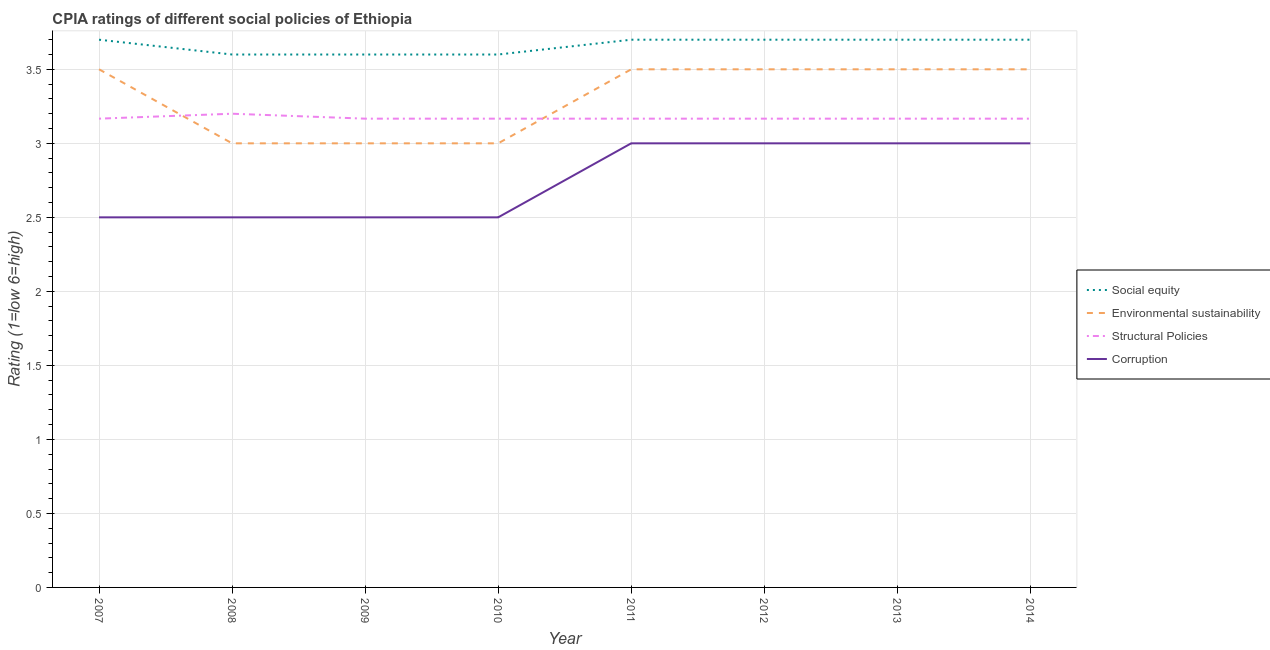How many different coloured lines are there?
Provide a succinct answer. 4. Is the number of lines equal to the number of legend labels?
Offer a terse response. Yes. Across all years, what is the maximum cpia rating of environmental sustainability?
Your answer should be compact. 3.5. What is the total cpia rating of social equity in the graph?
Keep it short and to the point. 29.3. What is the difference between the cpia rating of corruption in 2013 and that in 2014?
Keep it short and to the point. 0. What is the difference between the cpia rating of environmental sustainability in 2009 and the cpia rating of structural policies in 2010?
Provide a short and direct response. -0.17. What is the average cpia rating of structural policies per year?
Offer a terse response. 3.17. In the year 2013, what is the difference between the cpia rating of social equity and cpia rating of structural policies?
Provide a succinct answer. 0.53. In how many years, is the cpia rating of structural policies greater than 3?
Keep it short and to the point. 8. What is the ratio of the cpia rating of structural policies in 2009 to that in 2014?
Keep it short and to the point. 1. What is the difference between the highest and the second highest cpia rating of corruption?
Provide a succinct answer. 0. Is it the case that in every year, the sum of the cpia rating of social equity and cpia rating of environmental sustainability is greater than the cpia rating of structural policies?
Keep it short and to the point. Yes. How many years are there in the graph?
Ensure brevity in your answer.  8. Are the values on the major ticks of Y-axis written in scientific E-notation?
Your response must be concise. No. Does the graph contain any zero values?
Offer a very short reply. No. How many legend labels are there?
Provide a succinct answer. 4. What is the title of the graph?
Provide a short and direct response. CPIA ratings of different social policies of Ethiopia. Does "Social Awareness" appear as one of the legend labels in the graph?
Give a very brief answer. No. What is the label or title of the X-axis?
Provide a short and direct response. Year. What is the label or title of the Y-axis?
Your answer should be compact. Rating (1=low 6=high). What is the Rating (1=low 6=high) of Environmental sustainability in 2007?
Ensure brevity in your answer.  3.5. What is the Rating (1=low 6=high) of Structural Policies in 2007?
Offer a very short reply. 3.17. What is the Rating (1=low 6=high) of Corruption in 2007?
Provide a succinct answer. 2.5. What is the Rating (1=low 6=high) of Corruption in 2008?
Your answer should be very brief. 2.5. What is the Rating (1=low 6=high) in Structural Policies in 2009?
Keep it short and to the point. 3.17. What is the Rating (1=low 6=high) of Social equity in 2010?
Keep it short and to the point. 3.6. What is the Rating (1=low 6=high) of Environmental sustainability in 2010?
Make the answer very short. 3. What is the Rating (1=low 6=high) in Structural Policies in 2010?
Your answer should be compact. 3.17. What is the Rating (1=low 6=high) of Corruption in 2010?
Your response must be concise. 2.5. What is the Rating (1=low 6=high) in Environmental sustainability in 2011?
Provide a succinct answer. 3.5. What is the Rating (1=low 6=high) in Structural Policies in 2011?
Offer a very short reply. 3.17. What is the Rating (1=low 6=high) in Structural Policies in 2012?
Your answer should be very brief. 3.17. What is the Rating (1=low 6=high) of Corruption in 2012?
Offer a very short reply. 3. What is the Rating (1=low 6=high) of Structural Policies in 2013?
Your response must be concise. 3.17. What is the Rating (1=low 6=high) of Corruption in 2013?
Your response must be concise. 3. What is the Rating (1=low 6=high) in Social equity in 2014?
Provide a succinct answer. 3.7. What is the Rating (1=low 6=high) in Structural Policies in 2014?
Your response must be concise. 3.17. Across all years, what is the maximum Rating (1=low 6=high) in Social equity?
Provide a succinct answer. 3.7. Across all years, what is the maximum Rating (1=low 6=high) in Structural Policies?
Offer a very short reply. 3.2. Across all years, what is the minimum Rating (1=low 6=high) of Social equity?
Keep it short and to the point. 3.6. Across all years, what is the minimum Rating (1=low 6=high) in Structural Policies?
Ensure brevity in your answer.  3.17. What is the total Rating (1=low 6=high) of Social equity in the graph?
Your answer should be very brief. 29.3. What is the total Rating (1=low 6=high) in Structural Policies in the graph?
Ensure brevity in your answer.  25.37. What is the total Rating (1=low 6=high) of Corruption in the graph?
Your answer should be very brief. 22. What is the difference between the Rating (1=low 6=high) in Social equity in 2007 and that in 2008?
Keep it short and to the point. 0.1. What is the difference between the Rating (1=low 6=high) in Structural Policies in 2007 and that in 2008?
Provide a short and direct response. -0.03. What is the difference between the Rating (1=low 6=high) in Structural Policies in 2007 and that in 2009?
Your answer should be very brief. 0. What is the difference between the Rating (1=low 6=high) in Corruption in 2007 and that in 2010?
Your answer should be very brief. 0. What is the difference between the Rating (1=low 6=high) in Social equity in 2007 and that in 2011?
Your response must be concise. 0. What is the difference between the Rating (1=low 6=high) in Environmental sustainability in 2007 and that in 2011?
Offer a very short reply. 0. What is the difference between the Rating (1=low 6=high) in Structural Policies in 2007 and that in 2011?
Keep it short and to the point. 0. What is the difference between the Rating (1=low 6=high) of Corruption in 2007 and that in 2011?
Make the answer very short. -0.5. What is the difference between the Rating (1=low 6=high) in Social equity in 2007 and that in 2012?
Offer a terse response. 0. What is the difference between the Rating (1=low 6=high) of Environmental sustainability in 2007 and that in 2012?
Provide a succinct answer. 0. What is the difference between the Rating (1=low 6=high) in Corruption in 2007 and that in 2012?
Make the answer very short. -0.5. What is the difference between the Rating (1=low 6=high) of Environmental sustainability in 2007 and that in 2013?
Your answer should be compact. 0. What is the difference between the Rating (1=low 6=high) in Structural Policies in 2007 and that in 2013?
Your answer should be very brief. 0. What is the difference between the Rating (1=low 6=high) in Social equity in 2007 and that in 2014?
Provide a succinct answer. 0. What is the difference between the Rating (1=low 6=high) of Environmental sustainability in 2007 and that in 2014?
Offer a very short reply. 0. What is the difference between the Rating (1=low 6=high) of Corruption in 2007 and that in 2014?
Offer a very short reply. -0.5. What is the difference between the Rating (1=low 6=high) of Social equity in 2008 and that in 2009?
Provide a short and direct response. 0. What is the difference between the Rating (1=low 6=high) in Corruption in 2008 and that in 2009?
Offer a very short reply. 0. What is the difference between the Rating (1=low 6=high) of Social equity in 2008 and that in 2010?
Provide a succinct answer. 0. What is the difference between the Rating (1=low 6=high) of Structural Policies in 2008 and that in 2010?
Provide a short and direct response. 0.03. What is the difference between the Rating (1=low 6=high) of Environmental sustainability in 2008 and that in 2011?
Keep it short and to the point. -0.5. What is the difference between the Rating (1=low 6=high) in Corruption in 2008 and that in 2011?
Make the answer very short. -0.5. What is the difference between the Rating (1=low 6=high) in Structural Policies in 2008 and that in 2012?
Provide a short and direct response. 0.03. What is the difference between the Rating (1=low 6=high) in Social equity in 2008 and that in 2013?
Give a very brief answer. -0.1. What is the difference between the Rating (1=low 6=high) of Environmental sustainability in 2008 and that in 2013?
Offer a very short reply. -0.5. What is the difference between the Rating (1=low 6=high) of Environmental sustainability in 2008 and that in 2014?
Ensure brevity in your answer.  -0.5. What is the difference between the Rating (1=low 6=high) of Structural Policies in 2008 and that in 2014?
Provide a succinct answer. 0.03. What is the difference between the Rating (1=low 6=high) in Social equity in 2009 and that in 2010?
Give a very brief answer. 0. What is the difference between the Rating (1=low 6=high) in Environmental sustainability in 2009 and that in 2010?
Your response must be concise. 0. What is the difference between the Rating (1=low 6=high) in Structural Policies in 2009 and that in 2010?
Offer a very short reply. 0. What is the difference between the Rating (1=low 6=high) in Corruption in 2009 and that in 2010?
Provide a short and direct response. 0. What is the difference between the Rating (1=low 6=high) in Social equity in 2009 and that in 2011?
Ensure brevity in your answer.  -0.1. What is the difference between the Rating (1=low 6=high) of Environmental sustainability in 2009 and that in 2011?
Provide a succinct answer. -0.5. What is the difference between the Rating (1=low 6=high) in Corruption in 2009 and that in 2011?
Ensure brevity in your answer.  -0.5. What is the difference between the Rating (1=low 6=high) in Social equity in 2009 and that in 2012?
Your answer should be very brief. -0.1. What is the difference between the Rating (1=low 6=high) in Environmental sustainability in 2009 and that in 2012?
Keep it short and to the point. -0.5. What is the difference between the Rating (1=low 6=high) in Structural Policies in 2009 and that in 2012?
Your answer should be very brief. 0. What is the difference between the Rating (1=low 6=high) of Social equity in 2009 and that in 2013?
Provide a succinct answer. -0.1. What is the difference between the Rating (1=low 6=high) in Environmental sustainability in 2009 and that in 2013?
Offer a terse response. -0.5. What is the difference between the Rating (1=low 6=high) of Structural Policies in 2009 and that in 2013?
Give a very brief answer. 0. What is the difference between the Rating (1=low 6=high) of Social equity in 2009 and that in 2014?
Your answer should be very brief. -0.1. What is the difference between the Rating (1=low 6=high) in Structural Policies in 2009 and that in 2014?
Your answer should be compact. 0. What is the difference between the Rating (1=low 6=high) in Social equity in 2010 and that in 2011?
Your answer should be compact. -0.1. What is the difference between the Rating (1=low 6=high) in Structural Policies in 2010 and that in 2011?
Give a very brief answer. 0. What is the difference between the Rating (1=low 6=high) of Environmental sustainability in 2010 and that in 2012?
Make the answer very short. -0.5. What is the difference between the Rating (1=low 6=high) in Corruption in 2010 and that in 2012?
Make the answer very short. -0.5. What is the difference between the Rating (1=low 6=high) in Social equity in 2010 and that in 2013?
Ensure brevity in your answer.  -0.1. What is the difference between the Rating (1=low 6=high) of Environmental sustainability in 2010 and that in 2013?
Ensure brevity in your answer.  -0.5. What is the difference between the Rating (1=low 6=high) of Corruption in 2010 and that in 2013?
Make the answer very short. -0.5. What is the difference between the Rating (1=low 6=high) in Structural Policies in 2010 and that in 2014?
Make the answer very short. 0. What is the difference between the Rating (1=low 6=high) in Environmental sustainability in 2011 and that in 2012?
Offer a very short reply. 0. What is the difference between the Rating (1=low 6=high) in Corruption in 2011 and that in 2012?
Provide a succinct answer. 0. What is the difference between the Rating (1=low 6=high) in Structural Policies in 2011 and that in 2013?
Provide a succinct answer. 0. What is the difference between the Rating (1=low 6=high) in Environmental sustainability in 2011 and that in 2014?
Keep it short and to the point. 0. What is the difference between the Rating (1=low 6=high) of Corruption in 2011 and that in 2014?
Your answer should be compact. 0. What is the difference between the Rating (1=low 6=high) of Social equity in 2012 and that in 2013?
Give a very brief answer. 0. What is the difference between the Rating (1=low 6=high) in Environmental sustainability in 2012 and that in 2013?
Offer a very short reply. 0. What is the difference between the Rating (1=low 6=high) of Corruption in 2012 and that in 2013?
Keep it short and to the point. 0. What is the difference between the Rating (1=low 6=high) in Social equity in 2012 and that in 2014?
Give a very brief answer. 0. What is the difference between the Rating (1=low 6=high) of Environmental sustainability in 2012 and that in 2014?
Your answer should be compact. 0. What is the difference between the Rating (1=low 6=high) of Structural Policies in 2012 and that in 2014?
Your answer should be compact. 0. What is the difference between the Rating (1=low 6=high) in Environmental sustainability in 2013 and that in 2014?
Keep it short and to the point. 0. What is the difference between the Rating (1=low 6=high) in Structural Policies in 2013 and that in 2014?
Your answer should be very brief. 0. What is the difference between the Rating (1=low 6=high) of Social equity in 2007 and the Rating (1=low 6=high) of Structural Policies in 2008?
Offer a terse response. 0.5. What is the difference between the Rating (1=low 6=high) in Social equity in 2007 and the Rating (1=low 6=high) in Corruption in 2008?
Give a very brief answer. 1.2. What is the difference between the Rating (1=low 6=high) in Structural Policies in 2007 and the Rating (1=low 6=high) in Corruption in 2008?
Make the answer very short. 0.67. What is the difference between the Rating (1=low 6=high) in Social equity in 2007 and the Rating (1=low 6=high) in Environmental sustainability in 2009?
Give a very brief answer. 0.7. What is the difference between the Rating (1=low 6=high) of Social equity in 2007 and the Rating (1=low 6=high) of Structural Policies in 2009?
Ensure brevity in your answer.  0.53. What is the difference between the Rating (1=low 6=high) in Social equity in 2007 and the Rating (1=low 6=high) in Corruption in 2009?
Offer a terse response. 1.2. What is the difference between the Rating (1=low 6=high) in Environmental sustainability in 2007 and the Rating (1=low 6=high) in Structural Policies in 2009?
Provide a succinct answer. 0.33. What is the difference between the Rating (1=low 6=high) of Environmental sustainability in 2007 and the Rating (1=low 6=high) of Corruption in 2009?
Ensure brevity in your answer.  1. What is the difference between the Rating (1=low 6=high) in Social equity in 2007 and the Rating (1=low 6=high) in Environmental sustainability in 2010?
Keep it short and to the point. 0.7. What is the difference between the Rating (1=low 6=high) in Social equity in 2007 and the Rating (1=low 6=high) in Structural Policies in 2010?
Your answer should be very brief. 0.53. What is the difference between the Rating (1=low 6=high) in Social equity in 2007 and the Rating (1=low 6=high) in Corruption in 2010?
Keep it short and to the point. 1.2. What is the difference between the Rating (1=low 6=high) of Environmental sustainability in 2007 and the Rating (1=low 6=high) of Corruption in 2010?
Your response must be concise. 1. What is the difference between the Rating (1=low 6=high) of Social equity in 2007 and the Rating (1=low 6=high) of Environmental sustainability in 2011?
Keep it short and to the point. 0.2. What is the difference between the Rating (1=low 6=high) in Social equity in 2007 and the Rating (1=low 6=high) in Structural Policies in 2011?
Your answer should be very brief. 0.53. What is the difference between the Rating (1=low 6=high) of Environmental sustainability in 2007 and the Rating (1=low 6=high) of Structural Policies in 2011?
Provide a short and direct response. 0.33. What is the difference between the Rating (1=low 6=high) in Social equity in 2007 and the Rating (1=low 6=high) in Structural Policies in 2012?
Make the answer very short. 0.53. What is the difference between the Rating (1=low 6=high) in Environmental sustainability in 2007 and the Rating (1=low 6=high) in Structural Policies in 2012?
Give a very brief answer. 0.33. What is the difference between the Rating (1=low 6=high) of Social equity in 2007 and the Rating (1=low 6=high) of Structural Policies in 2013?
Your response must be concise. 0.53. What is the difference between the Rating (1=low 6=high) of Environmental sustainability in 2007 and the Rating (1=low 6=high) of Corruption in 2013?
Provide a short and direct response. 0.5. What is the difference between the Rating (1=low 6=high) of Structural Policies in 2007 and the Rating (1=low 6=high) of Corruption in 2013?
Provide a short and direct response. 0.17. What is the difference between the Rating (1=low 6=high) of Social equity in 2007 and the Rating (1=low 6=high) of Environmental sustainability in 2014?
Offer a very short reply. 0.2. What is the difference between the Rating (1=low 6=high) of Social equity in 2007 and the Rating (1=low 6=high) of Structural Policies in 2014?
Provide a succinct answer. 0.53. What is the difference between the Rating (1=low 6=high) of Social equity in 2007 and the Rating (1=low 6=high) of Corruption in 2014?
Offer a terse response. 0.7. What is the difference between the Rating (1=low 6=high) of Environmental sustainability in 2007 and the Rating (1=low 6=high) of Corruption in 2014?
Keep it short and to the point. 0.5. What is the difference between the Rating (1=low 6=high) of Structural Policies in 2007 and the Rating (1=low 6=high) of Corruption in 2014?
Ensure brevity in your answer.  0.17. What is the difference between the Rating (1=low 6=high) in Social equity in 2008 and the Rating (1=low 6=high) in Structural Policies in 2009?
Give a very brief answer. 0.43. What is the difference between the Rating (1=low 6=high) in Structural Policies in 2008 and the Rating (1=low 6=high) in Corruption in 2009?
Your answer should be very brief. 0.7. What is the difference between the Rating (1=low 6=high) of Social equity in 2008 and the Rating (1=low 6=high) of Environmental sustainability in 2010?
Make the answer very short. 0.6. What is the difference between the Rating (1=low 6=high) in Social equity in 2008 and the Rating (1=low 6=high) in Structural Policies in 2010?
Offer a very short reply. 0.43. What is the difference between the Rating (1=low 6=high) of Social equity in 2008 and the Rating (1=low 6=high) of Corruption in 2010?
Your answer should be compact. 1.1. What is the difference between the Rating (1=low 6=high) in Environmental sustainability in 2008 and the Rating (1=low 6=high) in Structural Policies in 2010?
Keep it short and to the point. -0.17. What is the difference between the Rating (1=low 6=high) of Structural Policies in 2008 and the Rating (1=low 6=high) of Corruption in 2010?
Provide a succinct answer. 0.7. What is the difference between the Rating (1=low 6=high) of Social equity in 2008 and the Rating (1=low 6=high) of Environmental sustainability in 2011?
Give a very brief answer. 0.1. What is the difference between the Rating (1=low 6=high) of Social equity in 2008 and the Rating (1=low 6=high) of Structural Policies in 2011?
Your answer should be very brief. 0.43. What is the difference between the Rating (1=low 6=high) in Environmental sustainability in 2008 and the Rating (1=low 6=high) in Corruption in 2011?
Provide a succinct answer. 0. What is the difference between the Rating (1=low 6=high) in Social equity in 2008 and the Rating (1=low 6=high) in Environmental sustainability in 2012?
Offer a terse response. 0.1. What is the difference between the Rating (1=low 6=high) of Social equity in 2008 and the Rating (1=low 6=high) of Structural Policies in 2012?
Offer a very short reply. 0.43. What is the difference between the Rating (1=low 6=high) in Environmental sustainability in 2008 and the Rating (1=low 6=high) in Structural Policies in 2012?
Keep it short and to the point. -0.17. What is the difference between the Rating (1=low 6=high) of Structural Policies in 2008 and the Rating (1=low 6=high) of Corruption in 2012?
Offer a terse response. 0.2. What is the difference between the Rating (1=low 6=high) in Social equity in 2008 and the Rating (1=low 6=high) in Structural Policies in 2013?
Keep it short and to the point. 0.43. What is the difference between the Rating (1=low 6=high) in Social equity in 2008 and the Rating (1=low 6=high) in Corruption in 2013?
Give a very brief answer. 0.6. What is the difference between the Rating (1=low 6=high) in Environmental sustainability in 2008 and the Rating (1=low 6=high) in Structural Policies in 2013?
Ensure brevity in your answer.  -0.17. What is the difference between the Rating (1=low 6=high) in Social equity in 2008 and the Rating (1=low 6=high) in Structural Policies in 2014?
Your answer should be compact. 0.43. What is the difference between the Rating (1=low 6=high) of Environmental sustainability in 2008 and the Rating (1=low 6=high) of Structural Policies in 2014?
Provide a succinct answer. -0.17. What is the difference between the Rating (1=low 6=high) of Environmental sustainability in 2008 and the Rating (1=low 6=high) of Corruption in 2014?
Your answer should be very brief. 0. What is the difference between the Rating (1=low 6=high) of Social equity in 2009 and the Rating (1=low 6=high) of Environmental sustainability in 2010?
Give a very brief answer. 0.6. What is the difference between the Rating (1=low 6=high) of Social equity in 2009 and the Rating (1=low 6=high) of Structural Policies in 2010?
Your answer should be very brief. 0.43. What is the difference between the Rating (1=low 6=high) in Environmental sustainability in 2009 and the Rating (1=low 6=high) in Corruption in 2010?
Your response must be concise. 0.5. What is the difference between the Rating (1=low 6=high) of Social equity in 2009 and the Rating (1=low 6=high) of Structural Policies in 2011?
Offer a terse response. 0.43. What is the difference between the Rating (1=low 6=high) of Social equity in 2009 and the Rating (1=low 6=high) of Corruption in 2011?
Make the answer very short. 0.6. What is the difference between the Rating (1=low 6=high) of Environmental sustainability in 2009 and the Rating (1=low 6=high) of Corruption in 2011?
Provide a short and direct response. 0. What is the difference between the Rating (1=low 6=high) of Social equity in 2009 and the Rating (1=low 6=high) of Structural Policies in 2012?
Keep it short and to the point. 0.43. What is the difference between the Rating (1=low 6=high) in Social equity in 2009 and the Rating (1=low 6=high) in Corruption in 2012?
Offer a terse response. 0.6. What is the difference between the Rating (1=low 6=high) in Environmental sustainability in 2009 and the Rating (1=low 6=high) in Corruption in 2012?
Your response must be concise. 0. What is the difference between the Rating (1=low 6=high) of Social equity in 2009 and the Rating (1=low 6=high) of Environmental sustainability in 2013?
Your answer should be very brief. 0.1. What is the difference between the Rating (1=low 6=high) in Social equity in 2009 and the Rating (1=low 6=high) in Structural Policies in 2013?
Provide a succinct answer. 0.43. What is the difference between the Rating (1=low 6=high) of Environmental sustainability in 2009 and the Rating (1=low 6=high) of Corruption in 2013?
Provide a short and direct response. 0. What is the difference between the Rating (1=low 6=high) in Social equity in 2009 and the Rating (1=low 6=high) in Environmental sustainability in 2014?
Offer a terse response. 0.1. What is the difference between the Rating (1=low 6=high) of Social equity in 2009 and the Rating (1=low 6=high) of Structural Policies in 2014?
Give a very brief answer. 0.43. What is the difference between the Rating (1=low 6=high) of Social equity in 2009 and the Rating (1=low 6=high) of Corruption in 2014?
Your response must be concise. 0.6. What is the difference between the Rating (1=low 6=high) of Environmental sustainability in 2009 and the Rating (1=low 6=high) of Structural Policies in 2014?
Ensure brevity in your answer.  -0.17. What is the difference between the Rating (1=low 6=high) of Social equity in 2010 and the Rating (1=low 6=high) of Environmental sustainability in 2011?
Offer a very short reply. 0.1. What is the difference between the Rating (1=low 6=high) in Social equity in 2010 and the Rating (1=low 6=high) in Structural Policies in 2011?
Provide a short and direct response. 0.43. What is the difference between the Rating (1=low 6=high) in Environmental sustainability in 2010 and the Rating (1=low 6=high) in Corruption in 2011?
Provide a short and direct response. 0. What is the difference between the Rating (1=low 6=high) in Social equity in 2010 and the Rating (1=low 6=high) in Structural Policies in 2012?
Provide a succinct answer. 0.43. What is the difference between the Rating (1=low 6=high) in Environmental sustainability in 2010 and the Rating (1=low 6=high) in Structural Policies in 2012?
Provide a succinct answer. -0.17. What is the difference between the Rating (1=low 6=high) in Environmental sustainability in 2010 and the Rating (1=low 6=high) in Corruption in 2012?
Offer a terse response. 0. What is the difference between the Rating (1=low 6=high) of Social equity in 2010 and the Rating (1=low 6=high) of Structural Policies in 2013?
Your response must be concise. 0.43. What is the difference between the Rating (1=low 6=high) in Environmental sustainability in 2010 and the Rating (1=low 6=high) in Corruption in 2013?
Give a very brief answer. 0. What is the difference between the Rating (1=low 6=high) in Social equity in 2010 and the Rating (1=low 6=high) in Structural Policies in 2014?
Your answer should be compact. 0.43. What is the difference between the Rating (1=low 6=high) of Social equity in 2010 and the Rating (1=low 6=high) of Corruption in 2014?
Give a very brief answer. 0.6. What is the difference between the Rating (1=low 6=high) in Environmental sustainability in 2010 and the Rating (1=low 6=high) in Structural Policies in 2014?
Offer a very short reply. -0.17. What is the difference between the Rating (1=low 6=high) in Social equity in 2011 and the Rating (1=low 6=high) in Structural Policies in 2012?
Provide a short and direct response. 0.53. What is the difference between the Rating (1=low 6=high) of Structural Policies in 2011 and the Rating (1=low 6=high) of Corruption in 2012?
Make the answer very short. 0.17. What is the difference between the Rating (1=low 6=high) in Social equity in 2011 and the Rating (1=low 6=high) in Environmental sustainability in 2013?
Provide a short and direct response. 0.2. What is the difference between the Rating (1=low 6=high) of Social equity in 2011 and the Rating (1=low 6=high) of Structural Policies in 2013?
Your answer should be very brief. 0.53. What is the difference between the Rating (1=low 6=high) in Environmental sustainability in 2011 and the Rating (1=low 6=high) in Corruption in 2013?
Your answer should be very brief. 0.5. What is the difference between the Rating (1=low 6=high) of Structural Policies in 2011 and the Rating (1=low 6=high) of Corruption in 2013?
Make the answer very short. 0.17. What is the difference between the Rating (1=low 6=high) in Social equity in 2011 and the Rating (1=low 6=high) in Structural Policies in 2014?
Keep it short and to the point. 0.53. What is the difference between the Rating (1=low 6=high) in Social equity in 2011 and the Rating (1=low 6=high) in Corruption in 2014?
Give a very brief answer. 0.7. What is the difference between the Rating (1=low 6=high) of Social equity in 2012 and the Rating (1=low 6=high) of Environmental sustainability in 2013?
Provide a succinct answer. 0.2. What is the difference between the Rating (1=low 6=high) in Social equity in 2012 and the Rating (1=low 6=high) in Structural Policies in 2013?
Ensure brevity in your answer.  0.53. What is the difference between the Rating (1=low 6=high) of Social equity in 2012 and the Rating (1=low 6=high) of Corruption in 2013?
Give a very brief answer. 0.7. What is the difference between the Rating (1=low 6=high) in Environmental sustainability in 2012 and the Rating (1=low 6=high) in Structural Policies in 2013?
Offer a very short reply. 0.33. What is the difference between the Rating (1=low 6=high) of Environmental sustainability in 2012 and the Rating (1=low 6=high) of Corruption in 2013?
Your response must be concise. 0.5. What is the difference between the Rating (1=low 6=high) of Structural Policies in 2012 and the Rating (1=low 6=high) of Corruption in 2013?
Ensure brevity in your answer.  0.17. What is the difference between the Rating (1=low 6=high) of Social equity in 2012 and the Rating (1=low 6=high) of Environmental sustainability in 2014?
Ensure brevity in your answer.  0.2. What is the difference between the Rating (1=low 6=high) in Social equity in 2012 and the Rating (1=low 6=high) in Structural Policies in 2014?
Provide a succinct answer. 0.53. What is the difference between the Rating (1=low 6=high) of Social equity in 2012 and the Rating (1=low 6=high) of Corruption in 2014?
Make the answer very short. 0.7. What is the difference between the Rating (1=low 6=high) in Environmental sustainability in 2012 and the Rating (1=low 6=high) in Structural Policies in 2014?
Provide a succinct answer. 0.33. What is the difference between the Rating (1=low 6=high) in Structural Policies in 2012 and the Rating (1=low 6=high) in Corruption in 2014?
Offer a terse response. 0.17. What is the difference between the Rating (1=low 6=high) in Social equity in 2013 and the Rating (1=low 6=high) in Environmental sustainability in 2014?
Make the answer very short. 0.2. What is the difference between the Rating (1=low 6=high) in Social equity in 2013 and the Rating (1=low 6=high) in Structural Policies in 2014?
Offer a very short reply. 0.53. What is the difference between the Rating (1=low 6=high) of Environmental sustainability in 2013 and the Rating (1=low 6=high) of Structural Policies in 2014?
Ensure brevity in your answer.  0.33. What is the difference between the Rating (1=low 6=high) of Structural Policies in 2013 and the Rating (1=low 6=high) of Corruption in 2014?
Your answer should be very brief. 0.17. What is the average Rating (1=low 6=high) in Social equity per year?
Ensure brevity in your answer.  3.66. What is the average Rating (1=low 6=high) in Environmental sustainability per year?
Provide a succinct answer. 3.31. What is the average Rating (1=low 6=high) of Structural Policies per year?
Your answer should be very brief. 3.17. What is the average Rating (1=low 6=high) in Corruption per year?
Your answer should be compact. 2.75. In the year 2007, what is the difference between the Rating (1=low 6=high) of Social equity and Rating (1=low 6=high) of Environmental sustainability?
Offer a terse response. 0.2. In the year 2007, what is the difference between the Rating (1=low 6=high) of Social equity and Rating (1=low 6=high) of Structural Policies?
Provide a short and direct response. 0.53. In the year 2007, what is the difference between the Rating (1=low 6=high) in Social equity and Rating (1=low 6=high) in Corruption?
Offer a very short reply. 1.2. In the year 2007, what is the difference between the Rating (1=low 6=high) in Environmental sustainability and Rating (1=low 6=high) in Corruption?
Provide a succinct answer. 1. In the year 2008, what is the difference between the Rating (1=low 6=high) in Social equity and Rating (1=low 6=high) in Structural Policies?
Make the answer very short. 0.4. In the year 2008, what is the difference between the Rating (1=low 6=high) in Environmental sustainability and Rating (1=low 6=high) in Structural Policies?
Keep it short and to the point. -0.2. In the year 2009, what is the difference between the Rating (1=low 6=high) in Social equity and Rating (1=low 6=high) in Environmental sustainability?
Provide a short and direct response. 0.6. In the year 2009, what is the difference between the Rating (1=low 6=high) in Social equity and Rating (1=low 6=high) in Structural Policies?
Ensure brevity in your answer.  0.43. In the year 2009, what is the difference between the Rating (1=low 6=high) in Social equity and Rating (1=low 6=high) in Corruption?
Make the answer very short. 1.1. In the year 2009, what is the difference between the Rating (1=low 6=high) of Environmental sustainability and Rating (1=low 6=high) of Structural Policies?
Your answer should be compact. -0.17. In the year 2009, what is the difference between the Rating (1=low 6=high) of Environmental sustainability and Rating (1=low 6=high) of Corruption?
Provide a succinct answer. 0.5. In the year 2010, what is the difference between the Rating (1=low 6=high) of Social equity and Rating (1=low 6=high) of Structural Policies?
Keep it short and to the point. 0.43. In the year 2010, what is the difference between the Rating (1=low 6=high) of Social equity and Rating (1=low 6=high) of Corruption?
Keep it short and to the point. 1.1. In the year 2010, what is the difference between the Rating (1=low 6=high) of Environmental sustainability and Rating (1=low 6=high) of Structural Policies?
Ensure brevity in your answer.  -0.17. In the year 2010, what is the difference between the Rating (1=low 6=high) in Structural Policies and Rating (1=low 6=high) in Corruption?
Your answer should be very brief. 0.67. In the year 2011, what is the difference between the Rating (1=low 6=high) of Social equity and Rating (1=low 6=high) of Structural Policies?
Ensure brevity in your answer.  0.53. In the year 2011, what is the difference between the Rating (1=low 6=high) in Environmental sustainability and Rating (1=low 6=high) in Structural Policies?
Provide a succinct answer. 0.33. In the year 2011, what is the difference between the Rating (1=low 6=high) in Environmental sustainability and Rating (1=low 6=high) in Corruption?
Your answer should be compact. 0.5. In the year 2011, what is the difference between the Rating (1=low 6=high) of Structural Policies and Rating (1=low 6=high) of Corruption?
Provide a succinct answer. 0.17. In the year 2012, what is the difference between the Rating (1=low 6=high) of Social equity and Rating (1=low 6=high) of Environmental sustainability?
Provide a short and direct response. 0.2. In the year 2012, what is the difference between the Rating (1=low 6=high) in Social equity and Rating (1=low 6=high) in Structural Policies?
Your answer should be very brief. 0.53. In the year 2012, what is the difference between the Rating (1=low 6=high) in Social equity and Rating (1=low 6=high) in Corruption?
Offer a very short reply. 0.7. In the year 2012, what is the difference between the Rating (1=low 6=high) of Environmental sustainability and Rating (1=low 6=high) of Structural Policies?
Keep it short and to the point. 0.33. In the year 2012, what is the difference between the Rating (1=low 6=high) in Environmental sustainability and Rating (1=low 6=high) in Corruption?
Make the answer very short. 0.5. In the year 2013, what is the difference between the Rating (1=low 6=high) in Social equity and Rating (1=low 6=high) in Environmental sustainability?
Keep it short and to the point. 0.2. In the year 2013, what is the difference between the Rating (1=low 6=high) in Social equity and Rating (1=low 6=high) in Structural Policies?
Ensure brevity in your answer.  0.53. In the year 2013, what is the difference between the Rating (1=low 6=high) of Social equity and Rating (1=low 6=high) of Corruption?
Your answer should be compact. 0.7. In the year 2013, what is the difference between the Rating (1=low 6=high) of Structural Policies and Rating (1=low 6=high) of Corruption?
Your answer should be compact. 0.17. In the year 2014, what is the difference between the Rating (1=low 6=high) of Social equity and Rating (1=low 6=high) of Structural Policies?
Make the answer very short. 0.53. In the year 2014, what is the difference between the Rating (1=low 6=high) of Environmental sustainability and Rating (1=low 6=high) of Corruption?
Your answer should be compact. 0.5. In the year 2014, what is the difference between the Rating (1=low 6=high) in Structural Policies and Rating (1=low 6=high) in Corruption?
Ensure brevity in your answer.  0.17. What is the ratio of the Rating (1=low 6=high) of Social equity in 2007 to that in 2008?
Provide a short and direct response. 1.03. What is the ratio of the Rating (1=low 6=high) in Social equity in 2007 to that in 2009?
Offer a very short reply. 1.03. What is the ratio of the Rating (1=low 6=high) in Corruption in 2007 to that in 2009?
Offer a very short reply. 1. What is the ratio of the Rating (1=low 6=high) of Social equity in 2007 to that in 2010?
Ensure brevity in your answer.  1.03. What is the ratio of the Rating (1=low 6=high) of Environmental sustainability in 2007 to that in 2010?
Your answer should be compact. 1.17. What is the ratio of the Rating (1=low 6=high) in Structural Policies in 2007 to that in 2010?
Offer a terse response. 1. What is the ratio of the Rating (1=low 6=high) in Structural Policies in 2007 to that in 2011?
Your response must be concise. 1. What is the ratio of the Rating (1=low 6=high) of Corruption in 2007 to that in 2011?
Your answer should be compact. 0.83. What is the ratio of the Rating (1=low 6=high) of Social equity in 2007 to that in 2012?
Keep it short and to the point. 1. What is the ratio of the Rating (1=low 6=high) of Environmental sustainability in 2007 to that in 2012?
Your answer should be compact. 1. What is the ratio of the Rating (1=low 6=high) of Structural Policies in 2007 to that in 2012?
Provide a succinct answer. 1. What is the ratio of the Rating (1=low 6=high) of Corruption in 2007 to that in 2012?
Keep it short and to the point. 0.83. What is the ratio of the Rating (1=low 6=high) in Social equity in 2007 to that in 2013?
Your answer should be compact. 1. What is the ratio of the Rating (1=low 6=high) in Corruption in 2007 to that in 2013?
Provide a short and direct response. 0.83. What is the ratio of the Rating (1=low 6=high) in Corruption in 2007 to that in 2014?
Keep it short and to the point. 0.83. What is the ratio of the Rating (1=low 6=high) in Structural Policies in 2008 to that in 2009?
Provide a succinct answer. 1.01. What is the ratio of the Rating (1=low 6=high) in Corruption in 2008 to that in 2009?
Offer a very short reply. 1. What is the ratio of the Rating (1=low 6=high) in Social equity in 2008 to that in 2010?
Offer a terse response. 1. What is the ratio of the Rating (1=low 6=high) of Environmental sustainability in 2008 to that in 2010?
Offer a terse response. 1. What is the ratio of the Rating (1=low 6=high) in Structural Policies in 2008 to that in 2010?
Your answer should be very brief. 1.01. What is the ratio of the Rating (1=low 6=high) in Corruption in 2008 to that in 2010?
Your answer should be compact. 1. What is the ratio of the Rating (1=low 6=high) in Social equity in 2008 to that in 2011?
Your answer should be very brief. 0.97. What is the ratio of the Rating (1=low 6=high) of Environmental sustainability in 2008 to that in 2011?
Your response must be concise. 0.86. What is the ratio of the Rating (1=low 6=high) in Structural Policies in 2008 to that in 2011?
Your answer should be compact. 1.01. What is the ratio of the Rating (1=low 6=high) in Corruption in 2008 to that in 2011?
Provide a short and direct response. 0.83. What is the ratio of the Rating (1=low 6=high) of Social equity in 2008 to that in 2012?
Ensure brevity in your answer.  0.97. What is the ratio of the Rating (1=low 6=high) of Environmental sustainability in 2008 to that in 2012?
Provide a short and direct response. 0.86. What is the ratio of the Rating (1=low 6=high) in Structural Policies in 2008 to that in 2012?
Keep it short and to the point. 1.01. What is the ratio of the Rating (1=low 6=high) in Corruption in 2008 to that in 2012?
Provide a succinct answer. 0.83. What is the ratio of the Rating (1=low 6=high) in Structural Policies in 2008 to that in 2013?
Offer a terse response. 1.01. What is the ratio of the Rating (1=low 6=high) in Environmental sustainability in 2008 to that in 2014?
Offer a terse response. 0.86. What is the ratio of the Rating (1=low 6=high) of Structural Policies in 2008 to that in 2014?
Make the answer very short. 1.01. What is the ratio of the Rating (1=low 6=high) of Corruption in 2008 to that in 2014?
Make the answer very short. 0.83. What is the ratio of the Rating (1=low 6=high) in Social equity in 2009 to that in 2010?
Your response must be concise. 1. What is the ratio of the Rating (1=low 6=high) of Corruption in 2009 to that in 2010?
Provide a succinct answer. 1. What is the ratio of the Rating (1=low 6=high) in Environmental sustainability in 2009 to that in 2011?
Provide a succinct answer. 0.86. What is the ratio of the Rating (1=low 6=high) of Structural Policies in 2009 to that in 2011?
Ensure brevity in your answer.  1. What is the ratio of the Rating (1=low 6=high) of Environmental sustainability in 2009 to that in 2012?
Your answer should be compact. 0.86. What is the ratio of the Rating (1=low 6=high) in Structural Policies in 2009 to that in 2013?
Offer a very short reply. 1. What is the ratio of the Rating (1=low 6=high) in Environmental sustainability in 2009 to that in 2014?
Make the answer very short. 0.86. What is the ratio of the Rating (1=low 6=high) in Corruption in 2010 to that in 2011?
Make the answer very short. 0.83. What is the ratio of the Rating (1=low 6=high) of Social equity in 2010 to that in 2012?
Provide a short and direct response. 0.97. What is the ratio of the Rating (1=low 6=high) in Environmental sustainability in 2010 to that in 2012?
Your response must be concise. 0.86. What is the ratio of the Rating (1=low 6=high) of Social equity in 2010 to that in 2014?
Give a very brief answer. 0.97. What is the ratio of the Rating (1=low 6=high) of Social equity in 2011 to that in 2012?
Your answer should be very brief. 1. What is the ratio of the Rating (1=low 6=high) of Environmental sustainability in 2011 to that in 2012?
Your answer should be compact. 1. What is the ratio of the Rating (1=low 6=high) of Structural Policies in 2011 to that in 2012?
Your response must be concise. 1. What is the ratio of the Rating (1=low 6=high) in Corruption in 2011 to that in 2012?
Ensure brevity in your answer.  1. What is the ratio of the Rating (1=low 6=high) of Social equity in 2011 to that in 2013?
Your response must be concise. 1. What is the ratio of the Rating (1=low 6=high) of Structural Policies in 2011 to that in 2013?
Keep it short and to the point. 1. What is the ratio of the Rating (1=low 6=high) in Corruption in 2011 to that in 2013?
Your answer should be compact. 1. What is the ratio of the Rating (1=low 6=high) of Corruption in 2011 to that in 2014?
Provide a succinct answer. 1. What is the ratio of the Rating (1=low 6=high) in Environmental sustainability in 2012 to that in 2013?
Give a very brief answer. 1. What is the ratio of the Rating (1=low 6=high) of Social equity in 2012 to that in 2014?
Your answer should be very brief. 1. What is the ratio of the Rating (1=low 6=high) of Environmental sustainability in 2012 to that in 2014?
Give a very brief answer. 1. What is the ratio of the Rating (1=low 6=high) of Structural Policies in 2012 to that in 2014?
Offer a very short reply. 1. What is the ratio of the Rating (1=low 6=high) in Social equity in 2013 to that in 2014?
Ensure brevity in your answer.  1. What is the ratio of the Rating (1=low 6=high) of Environmental sustainability in 2013 to that in 2014?
Give a very brief answer. 1. What is the ratio of the Rating (1=low 6=high) in Corruption in 2013 to that in 2014?
Provide a short and direct response. 1. What is the difference between the highest and the second highest Rating (1=low 6=high) in Structural Policies?
Your response must be concise. 0.03. What is the difference between the highest and the second highest Rating (1=low 6=high) in Corruption?
Offer a very short reply. 0. What is the difference between the highest and the lowest Rating (1=low 6=high) in Environmental sustainability?
Offer a very short reply. 0.5. What is the difference between the highest and the lowest Rating (1=low 6=high) in Structural Policies?
Your answer should be very brief. 0.03. 